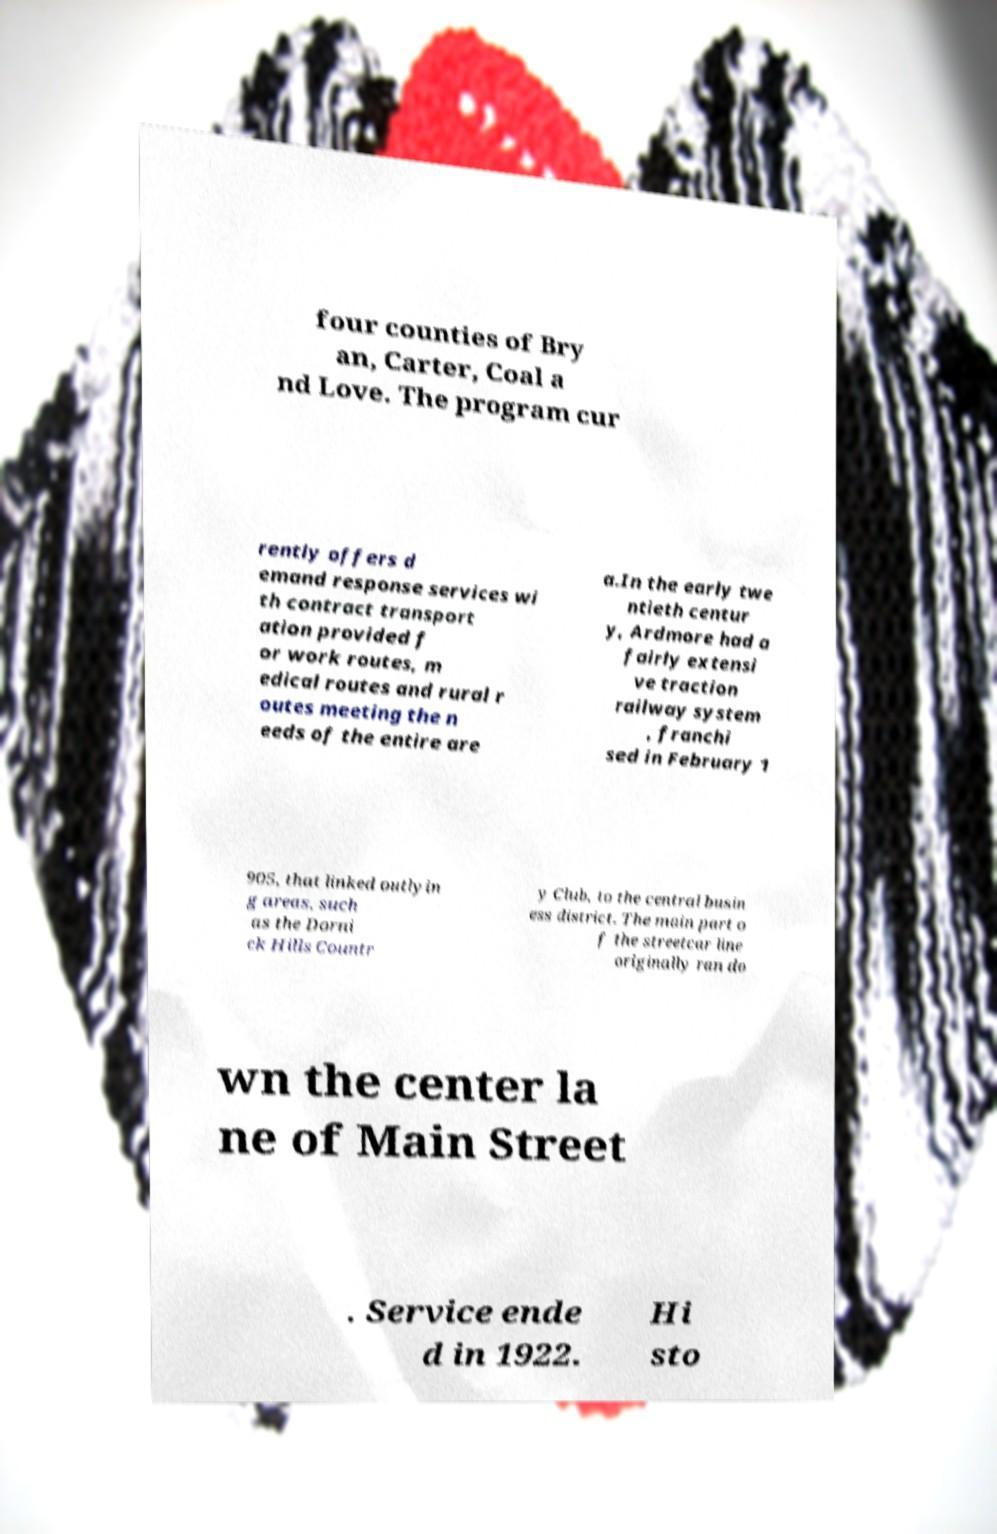For documentation purposes, I need the text within this image transcribed. Could you provide that? four counties of Bry an, Carter, Coal a nd Love. The program cur rently offers d emand response services wi th contract transport ation provided f or work routes, m edical routes and rural r outes meeting the n eeds of the entire are a.In the early twe ntieth centur y, Ardmore had a fairly extensi ve traction railway system , franchi sed in February 1 905, that linked outlyin g areas, such as the Dorni ck Hills Countr y Club, to the central busin ess district. The main part o f the streetcar line originally ran do wn the center la ne of Main Street . Service ende d in 1922. Hi sto 